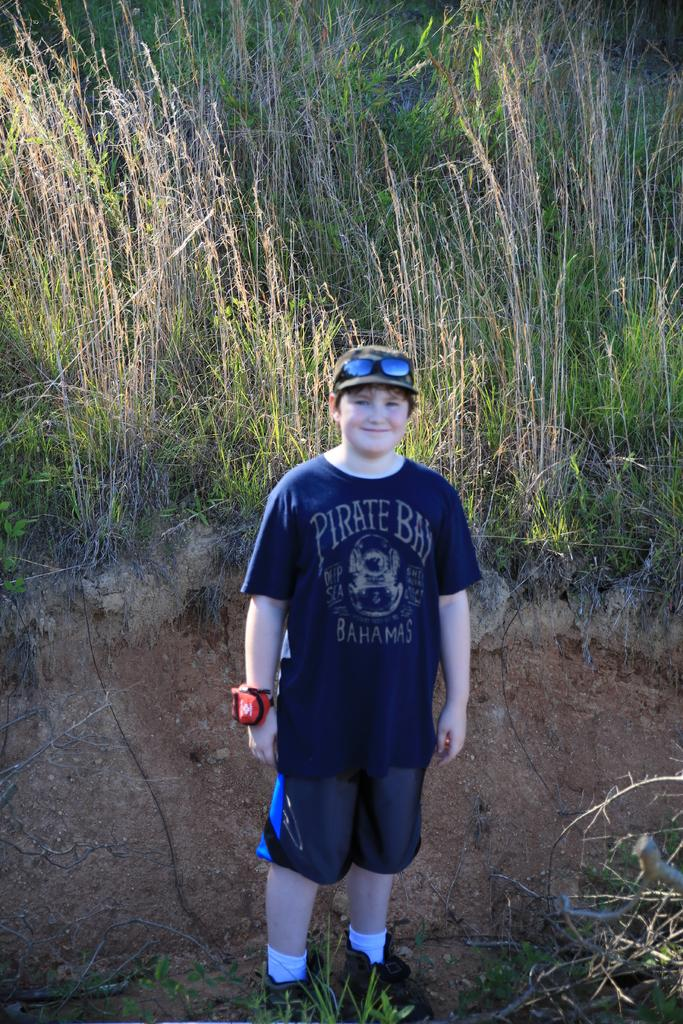What is the main subject of the image? The main subject of the image is a boy. What is the boy doing in the image? The boy is standing on the ground and smiling. What can be seen in the background of the image? There is grass visible in the background of the image. How far away is the cave from the boy in the image? There is no cave present in the image, so it cannot be determined how far away it is from the boy. 